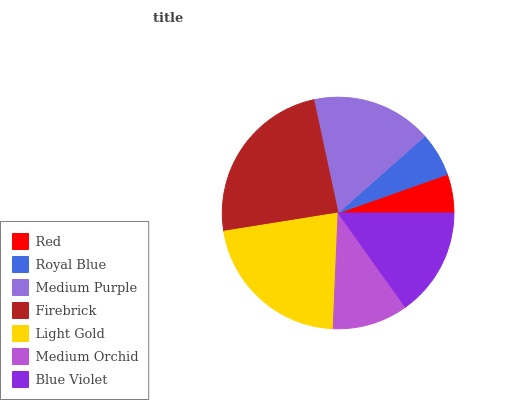Is Red the minimum?
Answer yes or no. Yes. Is Firebrick the maximum?
Answer yes or no. Yes. Is Royal Blue the minimum?
Answer yes or no. No. Is Royal Blue the maximum?
Answer yes or no. No. Is Royal Blue greater than Red?
Answer yes or no. Yes. Is Red less than Royal Blue?
Answer yes or no. Yes. Is Red greater than Royal Blue?
Answer yes or no. No. Is Royal Blue less than Red?
Answer yes or no. No. Is Blue Violet the high median?
Answer yes or no. Yes. Is Blue Violet the low median?
Answer yes or no. Yes. Is Royal Blue the high median?
Answer yes or no. No. Is Royal Blue the low median?
Answer yes or no. No. 